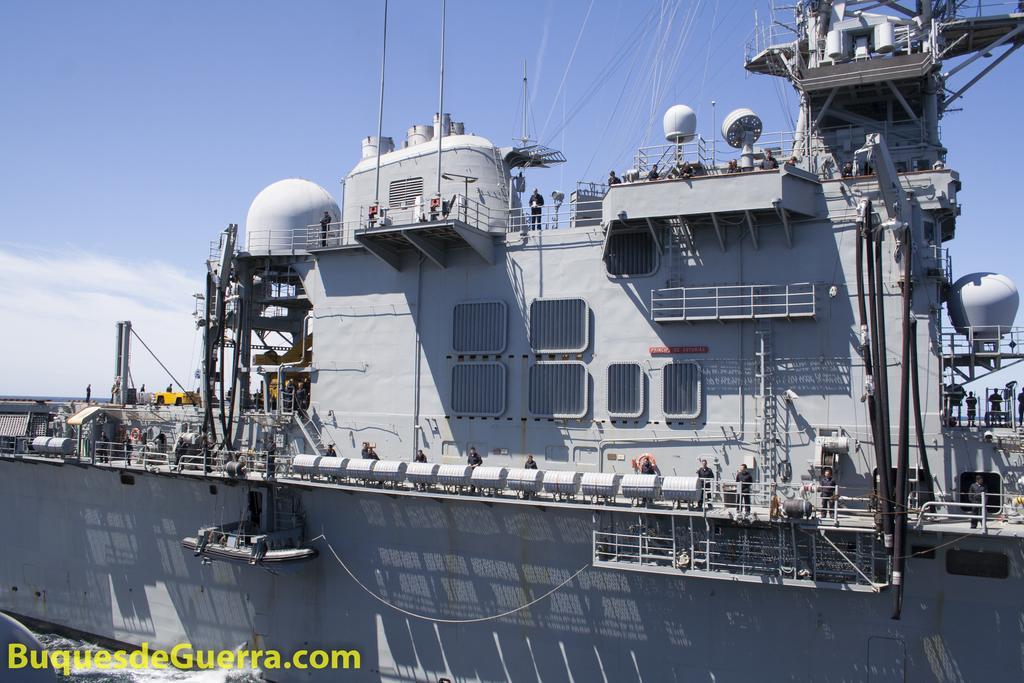Can you describe this image briefly? This image consists of a big ship in grey color. There are many people in the ship. All are wearing black dress. At the top, there are clouds in the sky. 